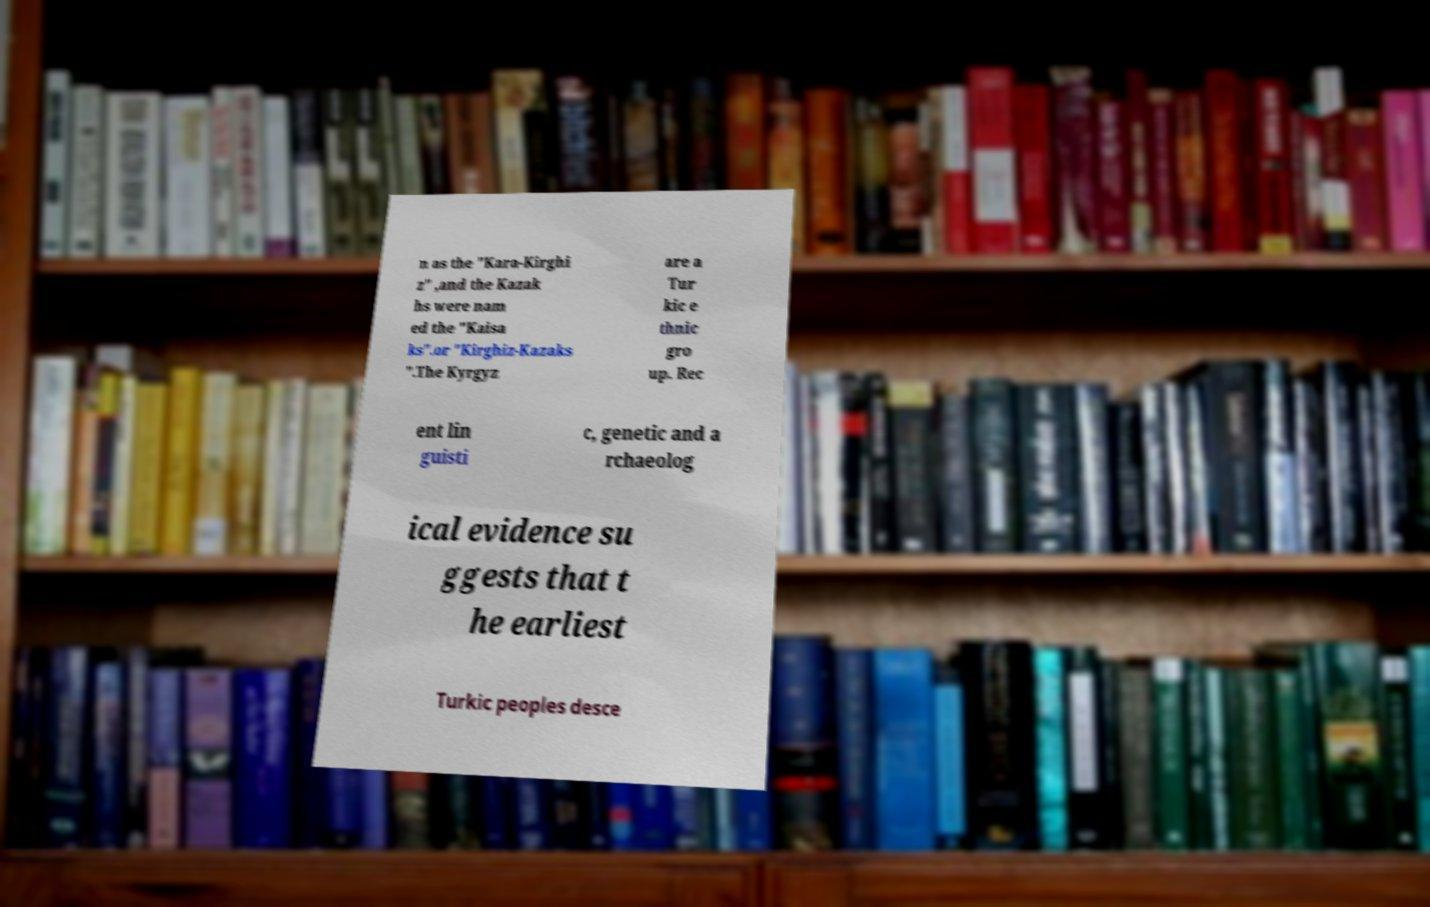There's text embedded in this image that I need extracted. Can you transcribe it verbatim? n as the "Kara-Kirghi z" ,and the Kazak hs were nam ed the "Kaisa ks".or "Kirghiz-Kazaks ".The Kyrgyz are a Tur kic e thnic gro up. Rec ent lin guisti c, genetic and a rchaeolog ical evidence su ggests that t he earliest Turkic peoples desce 